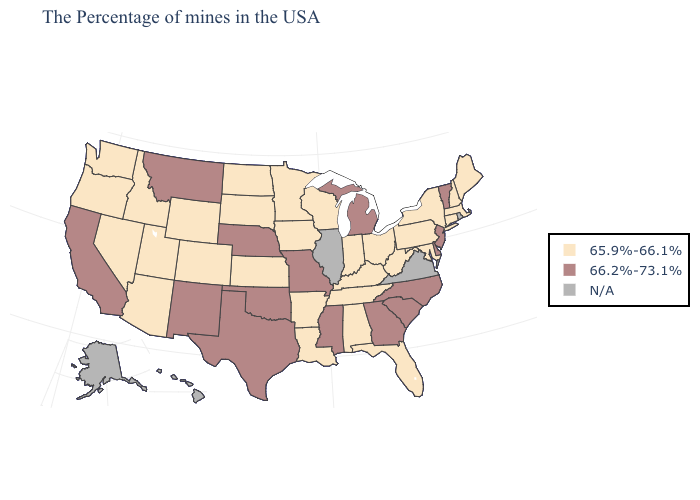How many symbols are there in the legend?
Give a very brief answer. 3. What is the value of Pennsylvania?
Keep it brief. 65.9%-66.1%. What is the highest value in the MidWest ?
Answer briefly. 66.2%-73.1%. Name the states that have a value in the range 66.2%-73.1%?
Concise answer only. Vermont, New Jersey, Delaware, North Carolina, South Carolina, Georgia, Michigan, Mississippi, Missouri, Nebraska, Oklahoma, Texas, New Mexico, Montana, California. What is the highest value in states that border Nevada?
Write a very short answer. 66.2%-73.1%. Does Minnesota have the highest value in the USA?
Keep it brief. No. Does Vermont have the lowest value in the Northeast?
Give a very brief answer. No. Is the legend a continuous bar?
Short answer required. No. What is the value of Louisiana?
Write a very short answer. 65.9%-66.1%. What is the value of California?
Answer briefly. 66.2%-73.1%. What is the highest value in states that border Wisconsin?
Give a very brief answer. 66.2%-73.1%. Among the states that border Kentucky , which have the lowest value?
Concise answer only. West Virginia, Ohio, Indiana, Tennessee. Which states hav the highest value in the South?
Answer briefly. Delaware, North Carolina, South Carolina, Georgia, Mississippi, Oklahoma, Texas. What is the highest value in the MidWest ?
Be succinct. 66.2%-73.1%. 